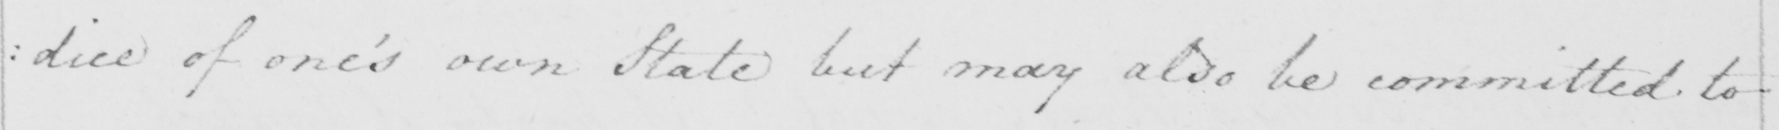Transcribe the text shown in this historical manuscript line. : dice of one ' s own State but may also be committed to 